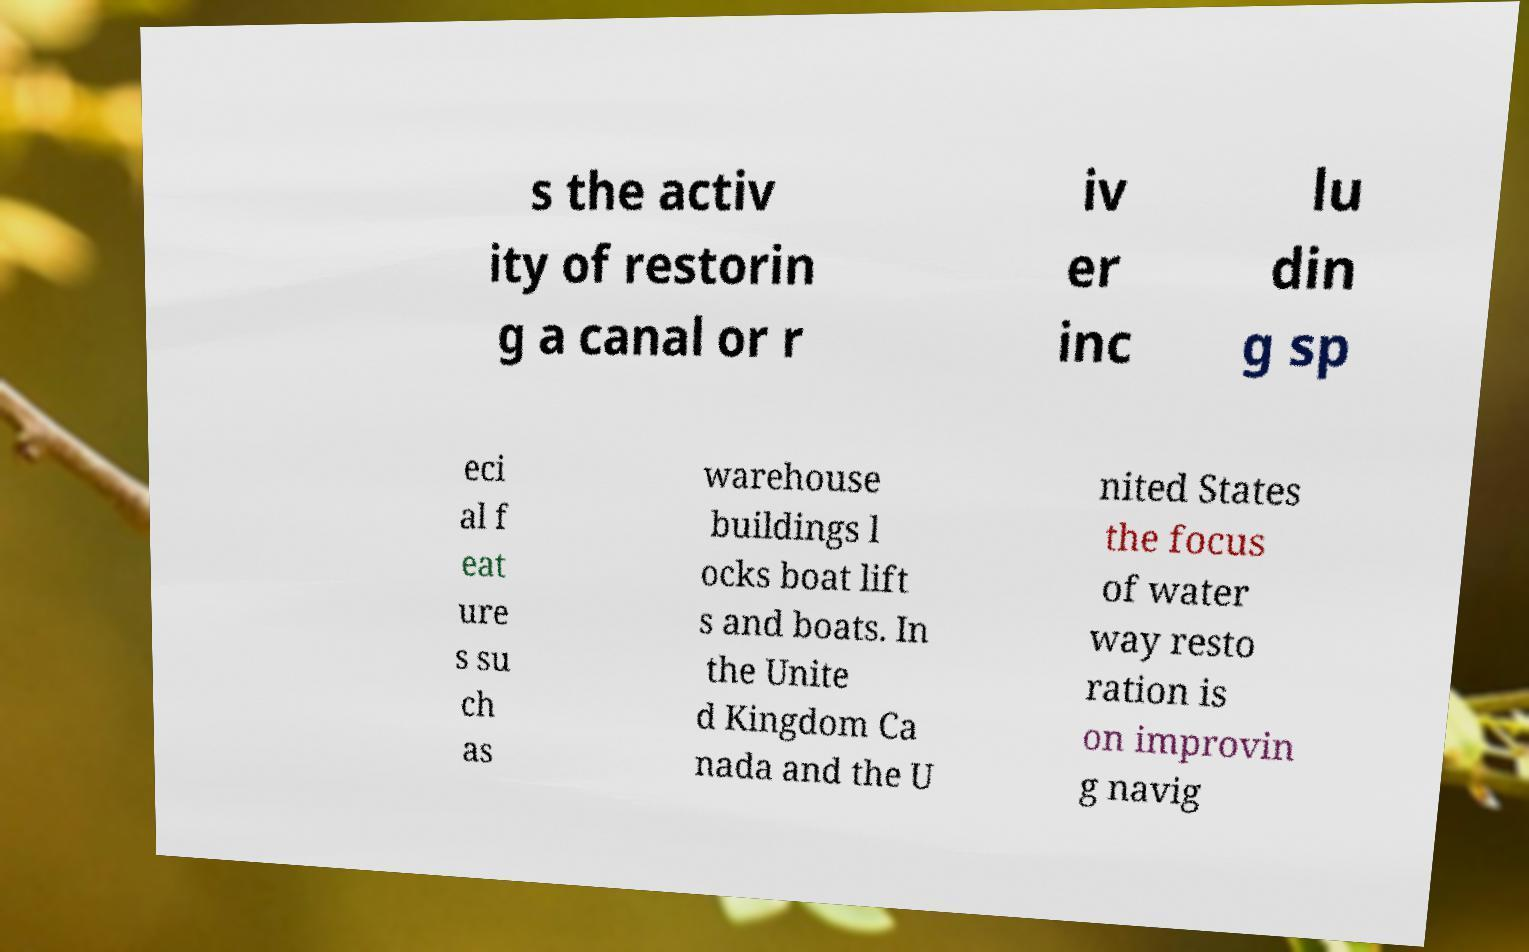Please identify and transcribe the text found in this image. s the activ ity of restorin g a canal or r iv er inc lu din g sp eci al f eat ure s su ch as warehouse buildings l ocks boat lift s and boats. In the Unite d Kingdom Ca nada and the U nited States the focus of water way resto ration is on improvin g navig 